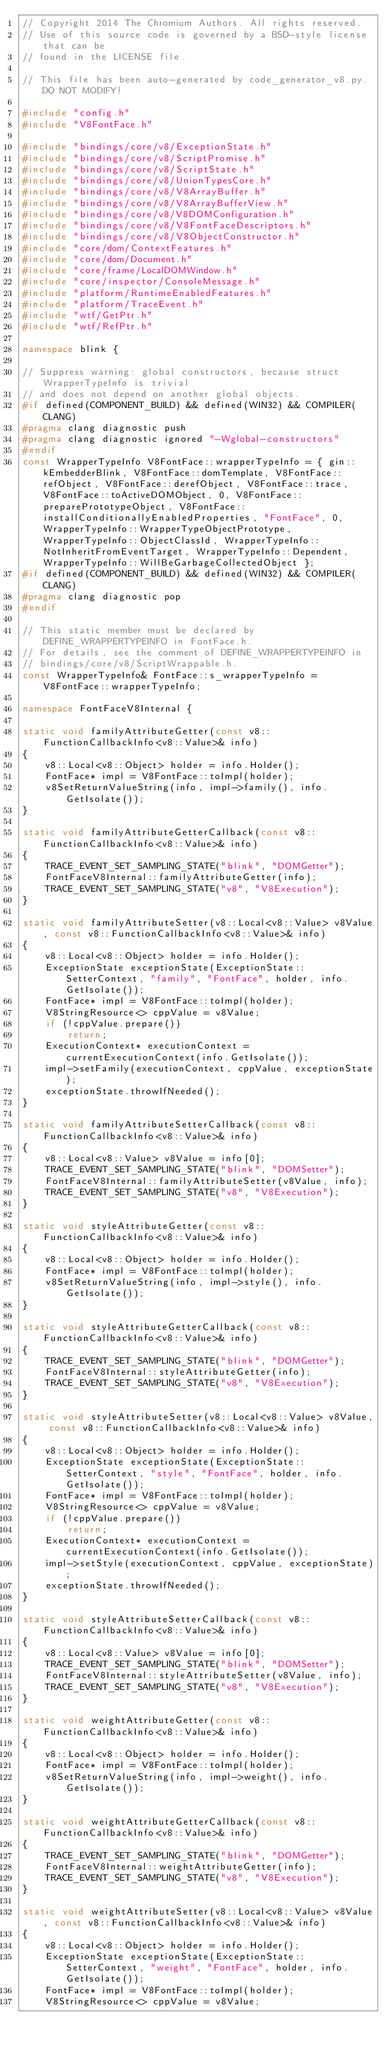<code> <loc_0><loc_0><loc_500><loc_500><_C++_>// Copyright 2014 The Chromium Authors. All rights reserved.
// Use of this source code is governed by a BSD-style license that can be
// found in the LICENSE file.

// This file has been auto-generated by code_generator_v8.py. DO NOT MODIFY!

#include "config.h"
#include "V8FontFace.h"

#include "bindings/core/v8/ExceptionState.h"
#include "bindings/core/v8/ScriptPromise.h"
#include "bindings/core/v8/ScriptState.h"
#include "bindings/core/v8/UnionTypesCore.h"
#include "bindings/core/v8/V8ArrayBuffer.h"
#include "bindings/core/v8/V8ArrayBufferView.h"
#include "bindings/core/v8/V8DOMConfiguration.h"
#include "bindings/core/v8/V8FontFaceDescriptors.h"
#include "bindings/core/v8/V8ObjectConstructor.h"
#include "core/dom/ContextFeatures.h"
#include "core/dom/Document.h"
#include "core/frame/LocalDOMWindow.h"
#include "core/inspector/ConsoleMessage.h"
#include "platform/RuntimeEnabledFeatures.h"
#include "platform/TraceEvent.h"
#include "wtf/GetPtr.h"
#include "wtf/RefPtr.h"

namespace blink {

// Suppress warning: global constructors, because struct WrapperTypeInfo is trivial
// and does not depend on another global objects.
#if defined(COMPONENT_BUILD) && defined(WIN32) && COMPILER(CLANG)
#pragma clang diagnostic push
#pragma clang diagnostic ignored "-Wglobal-constructors"
#endif
const WrapperTypeInfo V8FontFace::wrapperTypeInfo = { gin::kEmbedderBlink, V8FontFace::domTemplate, V8FontFace::refObject, V8FontFace::derefObject, V8FontFace::trace, V8FontFace::toActiveDOMObject, 0, V8FontFace::preparePrototypeObject, V8FontFace::installConditionallyEnabledProperties, "FontFace", 0, WrapperTypeInfo::WrapperTypeObjectPrototype, WrapperTypeInfo::ObjectClassId, WrapperTypeInfo::NotInheritFromEventTarget, WrapperTypeInfo::Dependent, WrapperTypeInfo::WillBeGarbageCollectedObject };
#if defined(COMPONENT_BUILD) && defined(WIN32) && COMPILER(CLANG)
#pragma clang diagnostic pop
#endif

// This static member must be declared by DEFINE_WRAPPERTYPEINFO in FontFace.h.
// For details, see the comment of DEFINE_WRAPPERTYPEINFO in
// bindings/core/v8/ScriptWrappable.h.
const WrapperTypeInfo& FontFace::s_wrapperTypeInfo = V8FontFace::wrapperTypeInfo;

namespace FontFaceV8Internal {

static void familyAttributeGetter(const v8::FunctionCallbackInfo<v8::Value>& info)
{
    v8::Local<v8::Object> holder = info.Holder();
    FontFace* impl = V8FontFace::toImpl(holder);
    v8SetReturnValueString(info, impl->family(), info.GetIsolate());
}

static void familyAttributeGetterCallback(const v8::FunctionCallbackInfo<v8::Value>& info)
{
    TRACE_EVENT_SET_SAMPLING_STATE("blink", "DOMGetter");
    FontFaceV8Internal::familyAttributeGetter(info);
    TRACE_EVENT_SET_SAMPLING_STATE("v8", "V8Execution");
}

static void familyAttributeSetter(v8::Local<v8::Value> v8Value, const v8::FunctionCallbackInfo<v8::Value>& info)
{
    v8::Local<v8::Object> holder = info.Holder();
    ExceptionState exceptionState(ExceptionState::SetterContext, "family", "FontFace", holder, info.GetIsolate());
    FontFace* impl = V8FontFace::toImpl(holder);
    V8StringResource<> cppValue = v8Value;
    if (!cppValue.prepare())
        return;
    ExecutionContext* executionContext = currentExecutionContext(info.GetIsolate());
    impl->setFamily(executionContext, cppValue, exceptionState);
    exceptionState.throwIfNeeded();
}

static void familyAttributeSetterCallback(const v8::FunctionCallbackInfo<v8::Value>& info)
{
    v8::Local<v8::Value> v8Value = info[0];
    TRACE_EVENT_SET_SAMPLING_STATE("blink", "DOMSetter");
    FontFaceV8Internal::familyAttributeSetter(v8Value, info);
    TRACE_EVENT_SET_SAMPLING_STATE("v8", "V8Execution");
}

static void styleAttributeGetter(const v8::FunctionCallbackInfo<v8::Value>& info)
{
    v8::Local<v8::Object> holder = info.Holder();
    FontFace* impl = V8FontFace::toImpl(holder);
    v8SetReturnValueString(info, impl->style(), info.GetIsolate());
}

static void styleAttributeGetterCallback(const v8::FunctionCallbackInfo<v8::Value>& info)
{
    TRACE_EVENT_SET_SAMPLING_STATE("blink", "DOMGetter");
    FontFaceV8Internal::styleAttributeGetter(info);
    TRACE_EVENT_SET_SAMPLING_STATE("v8", "V8Execution");
}

static void styleAttributeSetter(v8::Local<v8::Value> v8Value, const v8::FunctionCallbackInfo<v8::Value>& info)
{
    v8::Local<v8::Object> holder = info.Holder();
    ExceptionState exceptionState(ExceptionState::SetterContext, "style", "FontFace", holder, info.GetIsolate());
    FontFace* impl = V8FontFace::toImpl(holder);
    V8StringResource<> cppValue = v8Value;
    if (!cppValue.prepare())
        return;
    ExecutionContext* executionContext = currentExecutionContext(info.GetIsolate());
    impl->setStyle(executionContext, cppValue, exceptionState);
    exceptionState.throwIfNeeded();
}

static void styleAttributeSetterCallback(const v8::FunctionCallbackInfo<v8::Value>& info)
{
    v8::Local<v8::Value> v8Value = info[0];
    TRACE_EVENT_SET_SAMPLING_STATE("blink", "DOMSetter");
    FontFaceV8Internal::styleAttributeSetter(v8Value, info);
    TRACE_EVENT_SET_SAMPLING_STATE("v8", "V8Execution");
}

static void weightAttributeGetter(const v8::FunctionCallbackInfo<v8::Value>& info)
{
    v8::Local<v8::Object> holder = info.Holder();
    FontFace* impl = V8FontFace::toImpl(holder);
    v8SetReturnValueString(info, impl->weight(), info.GetIsolate());
}

static void weightAttributeGetterCallback(const v8::FunctionCallbackInfo<v8::Value>& info)
{
    TRACE_EVENT_SET_SAMPLING_STATE("blink", "DOMGetter");
    FontFaceV8Internal::weightAttributeGetter(info);
    TRACE_EVENT_SET_SAMPLING_STATE("v8", "V8Execution");
}

static void weightAttributeSetter(v8::Local<v8::Value> v8Value, const v8::FunctionCallbackInfo<v8::Value>& info)
{
    v8::Local<v8::Object> holder = info.Holder();
    ExceptionState exceptionState(ExceptionState::SetterContext, "weight", "FontFace", holder, info.GetIsolate());
    FontFace* impl = V8FontFace::toImpl(holder);
    V8StringResource<> cppValue = v8Value;</code> 